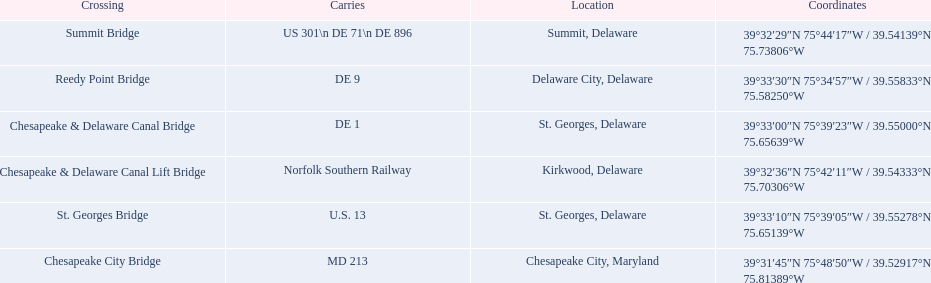What is being carried in the canal? MD 213, US 301\n DE 71\n DE 896, Norfolk Southern Railway, DE 1, U.S. 13, DE 9. Of those which has the largest number of different routes? US 301\n DE 71\n DE 896. To which crossing does that relate? Summit Bridge. 